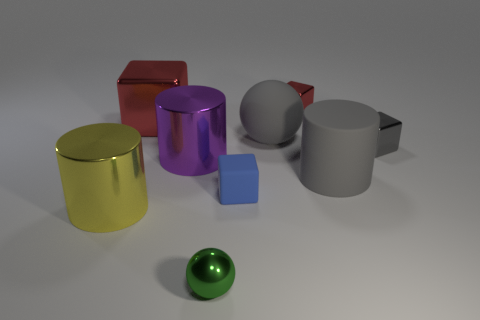Subtract all red cubes. How many were subtracted if there are1red cubes left? 1 Subtract all red cylinders. Subtract all brown balls. How many cylinders are left? 3 Add 1 small gray metal cubes. How many objects exist? 10 Subtract all balls. How many objects are left? 7 Add 4 rubber spheres. How many rubber spheres exist? 5 Subtract 1 green balls. How many objects are left? 8 Subtract all tiny gray shiny objects. Subtract all small red shiny cubes. How many objects are left? 7 Add 3 tiny gray things. How many tiny gray things are left? 4 